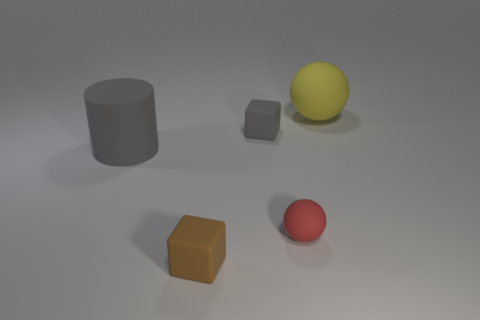Add 3 red shiny cubes. How many objects exist? 8 Subtract all cubes. How many objects are left? 3 Add 5 tiny brown objects. How many tiny brown objects are left? 6 Add 1 gray things. How many gray things exist? 3 Subtract 1 red balls. How many objects are left? 4 Subtract all small blocks. Subtract all matte balls. How many objects are left? 1 